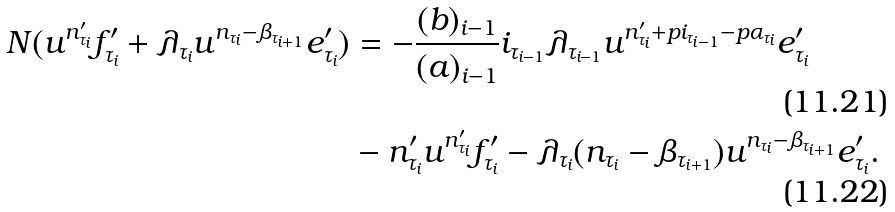Convert formula to latex. <formula><loc_0><loc_0><loc_500><loc_500>N ( u ^ { n ^ { \prime } _ { \tau _ { i } } } f ^ { \prime } _ { \tau _ { i } } + \lambda _ { \tau _ { i } } u ^ { n _ { \tau _ { i } } - \beta _ { \tau _ { i + 1 } } } e ^ { \prime } _ { \tau _ { i } } ) & = - \frac { ( b ) _ { i - 1 } } { ( a ) _ { i - 1 } } i _ { \tau _ { i - 1 } } \lambda _ { \tau _ { i - 1 } } u ^ { n ^ { \prime } _ { \tau _ { i } } + p i _ { \tau _ { i - 1 } } - p \alpha _ { \tau _ { i } } } e ^ { \prime } _ { \tau _ { i } } \\ & - n ^ { \prime } _ { \tau _ { i } } u ^ { n ^ { \prime } _ { \tau _ { i } } } f ^ { \prime } _ { \tau _ { i } } - \lambda _ { \tau _ { i } } ( n _ { \tau _ { i } } - \beta _ { \tau _ { i + 1 } } ) u ^ { n _ { \tau _ { i } } - \beta _ { \tau _ { i + 1 } } } e ^ { \prime } _ { \tau _ { i } } .</formula> 